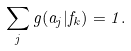Convert formula to latex. <formula><loc_0><loc_0><loc_500><loc_500>\sum _ { j } g ( a _ { j } | f _ { k } ) = 1 .</formula> 